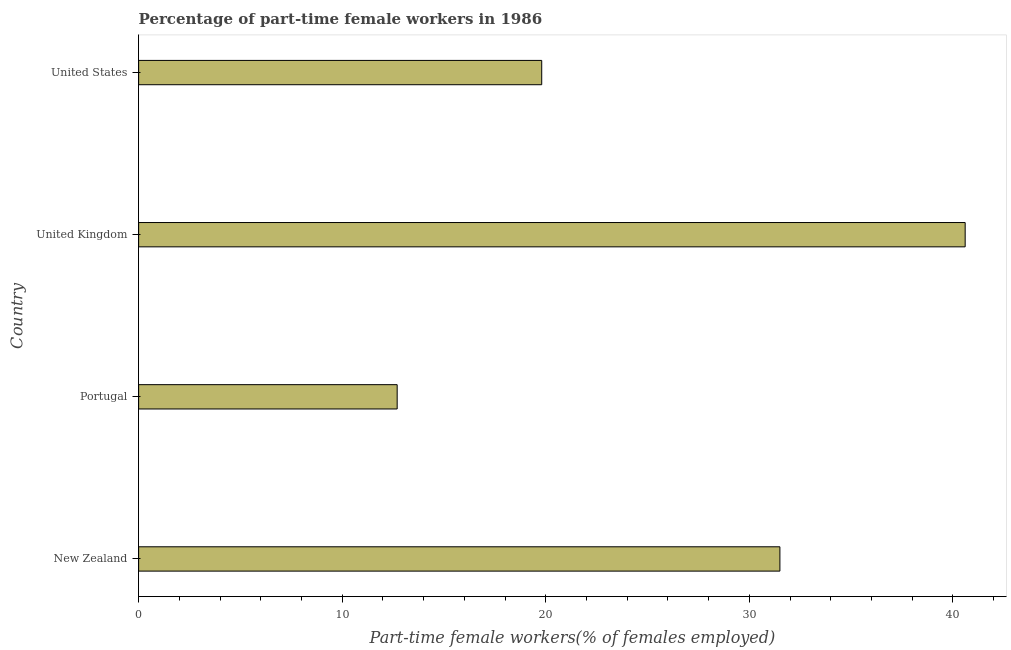Does the graph contain any zero values?
Provide a short and direct response. No. What is the title of the graph?
Ensure brevity in your answer.  Percentage of part-time female workers in 1986. What is the label or title of the X-axis?
Give a very brief answer. Part-time female workers(% of females employed). What is the percentage of part-time female workers in Portugal?
Provide a succinct answer. 12.7. Across all countries, what is the maximum percentage of part-time female workers?
Make the answer very short. 40.6. Across all countries, what is the minimum percentage of part-time female workers?
Your answer should be compact. 12.7. In which country was the percentage of part-time female workers minimum?
Keep it short and to the point. Portugal. What is the sum of the percentage of part-time female workers?
Make the answer very short. 104.6. What is the average percentage of part-time female workers per country?
Keep it short and to the point. 26.15. What is the median percentage of part-time female workers?
Provide a short and direct response. 25.65. What is the ratio of the percentage of part-time female workers in Portugal to that in United States?
Keep it short and to the point. 0.64. Is the difference between the percentage of part-time female workers in Portugal and United States greater than the difference between any two countries?
Provide a short and direct response. No. Is the sum of the percentage of part-time female workers in New Zealand and Portugal greater than the maximum percentage of part-time female workers across all countries?
Make the answer very short. Yes. What is the difference between the highest and the lowest percentage of part-time female workers?
Your answer should be compact. 27.9. In how many countries, is the percentage of part-time female workers greater than the average percentage of part-time female workers taken over all countries?
Offer a very short reply. 2. Are all the bars in the graph horizontal?
Your response must be concise. Yes. How many countries are there in the graph?
Offer a terse response. 4. Are the values on the major ticks of X-axis written in scientific E-notation?
Provide a succinct answer. No. What is the Part-time female workers(% of females employed) in New Zealand?
Offer a terse response. 31.5. What is the Part-time female workers(% of females employed) in Portugal?
Your answer should be very brief. 12.7. What is the Part-time female workers(% of females employed) of United Kingdom?
Provide a succinct answer. 40.6. What is the Part-time female workers(% of females employed) in United States?
Offer a terse response. 19.8. What is the difference between the Part-time female workers(% of females employed) in New Zealand and Portugal?
Give a very brief answer. 18.8. What is the difference between the Part-time female workers(% of females employed) in New Zealand and United States?
Offer a terse response. 11.7. What is the difference between the Part-time female workers(% of females employed) in Portugal and United Kingdom?
Provide a succinct answer. -27.9. What is the difference between the Part-time female workers(% of females employed) in United Kingdom and United States?
Your answer should be very brief. 20.8. What is the ratio of the Part-time female workers(% of females employed) in New Zealand to that in Portugal?
Your response must be concise. 2.48. What is the ratio of the Part-time female workers(% of females employed) in New Zealand to that in United Kingdom?
Your answer should be compact. 0.78. What is the ratio of the Part-time female workers(% of females employed) in New Zealand to that in United States?
Your response must be concise. 1.59. What is the ratio of the Part-time female workers(% of females employed) in Portugal to that in United Kingdom?
Offer a very short reply. 0.31. What is the ratio of the Part-time female workers(% of females employed) in Portugal to that in United States?
Your answer should be compact. 0.64. What is the ratio of the Part-time female workers(% of females employed) in United Kingdom to that in United States?
Your answer should be compact. 2.05. 